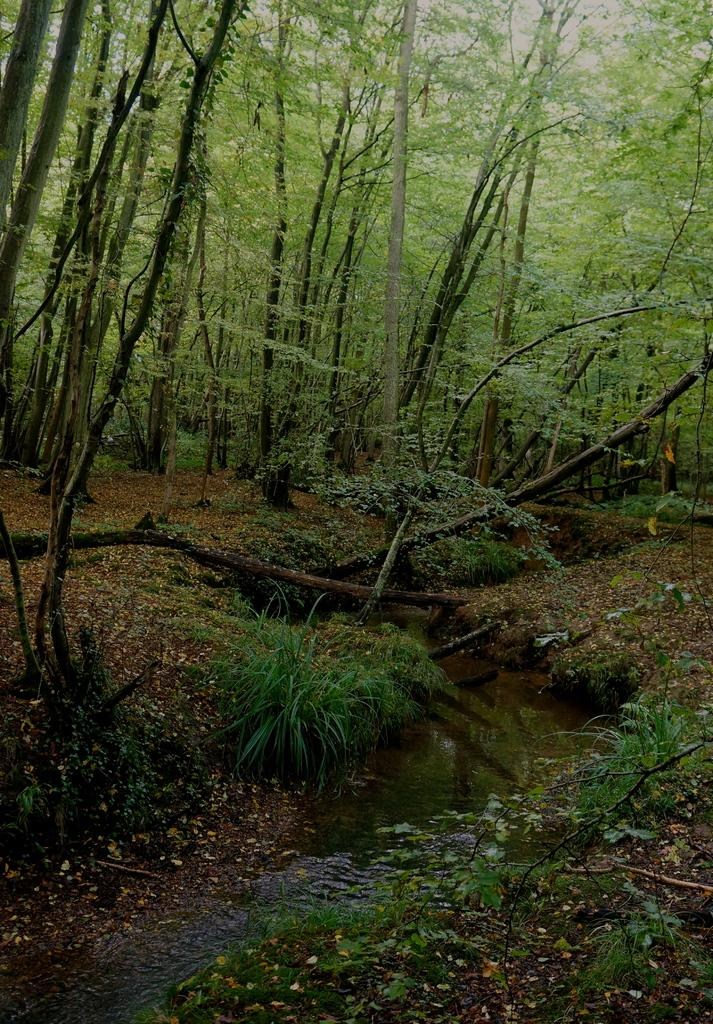What type of vegetation can be seen in the image? There are trees, grass, and plants visible in the image. What else can be seen in the image besides vegetation? There is water visible in the image. What type of bird can be seen bursting out of the water in the image? There is no bird present in the image, and no bursting out of the water is depicted. 